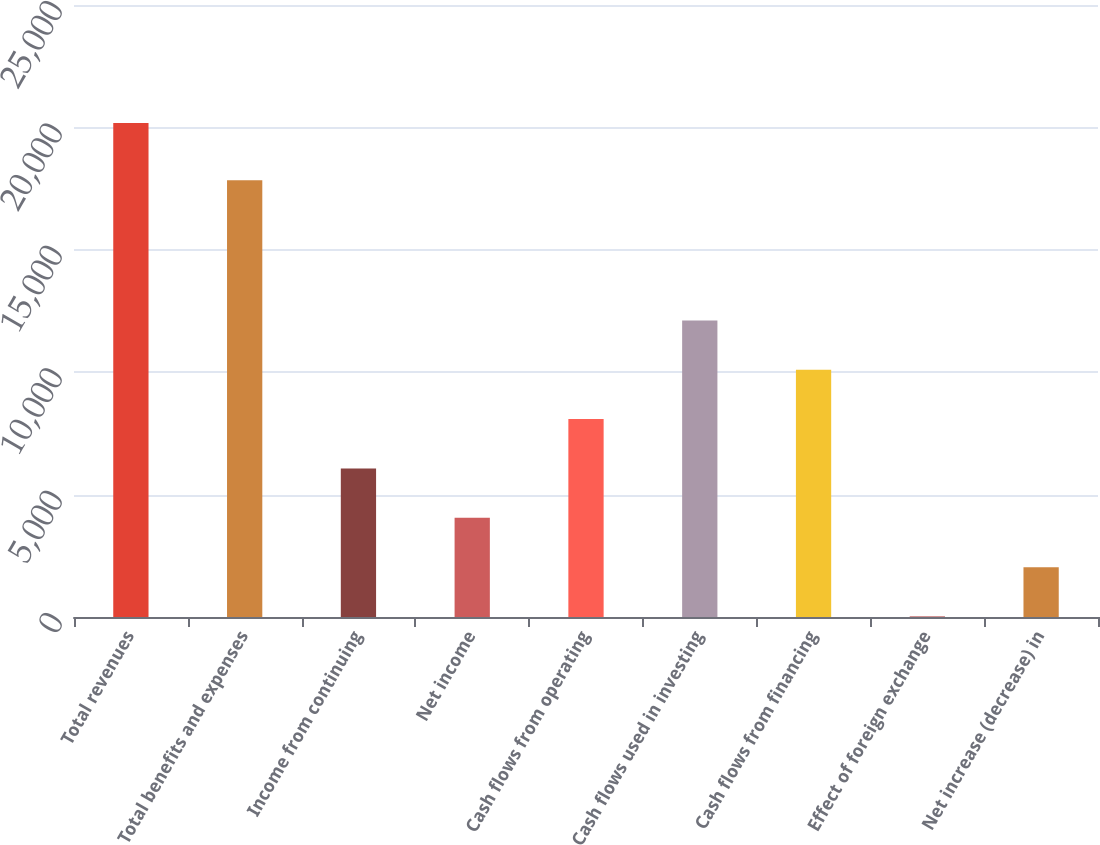Convert chart to OTSL. <chart><loc_0><loc_0><loc_500><loc_500><bar_chart><fcel>Total revenues<fcel>Total benefits and expenses<fcel>Income from continuing<fcel>Net income<fcel>Cash flows from operating<fcel>Cash flows used in investing<fcel>Cash flows from financing<fcel>Effect of foreign exchange<fcel>Net increase (decrease) in<nl><fcel>20184<fcel>17842<fcel>6066.4<fcel>4049.6<fcel>8083.2<fcel>12116.8<fcel>10100<fcel>16<fcel>2032.8<nl></chart> 